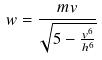<formula> <loc_0><loc_0><loc_500><loc_500>w = \frac { m v } { \sqrt { 5 - \frac { v ^ { 6 } } { h ^ { 6 } } } }</formula> 